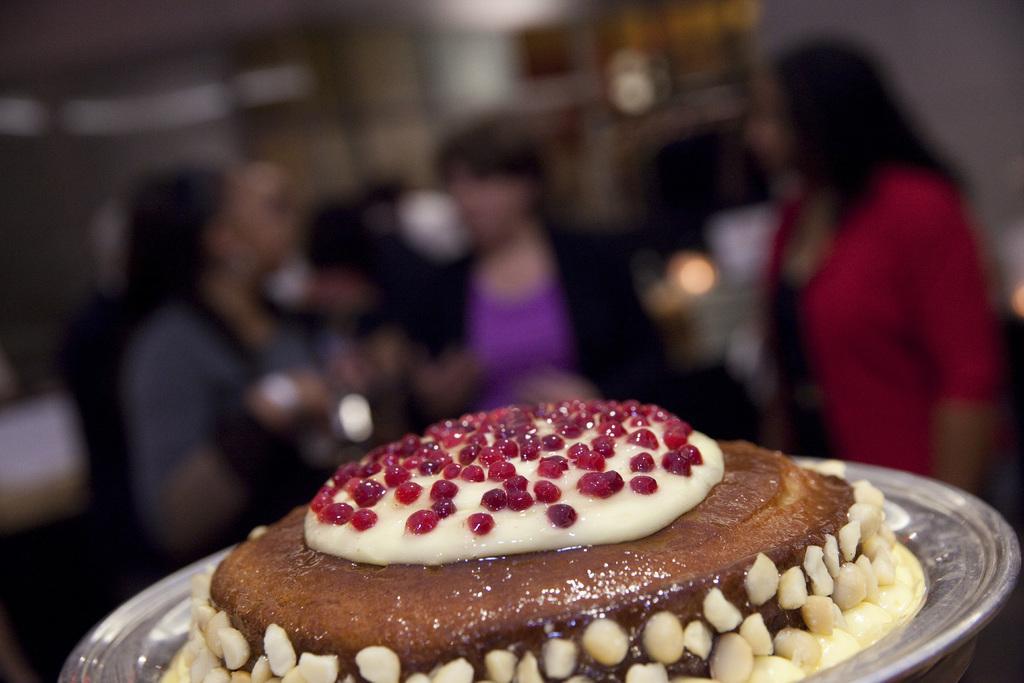How would you summarize this image in a sentence or two? In this image we can see a brown color food is decorated in a silver plate. Background of the image three women are standing. 